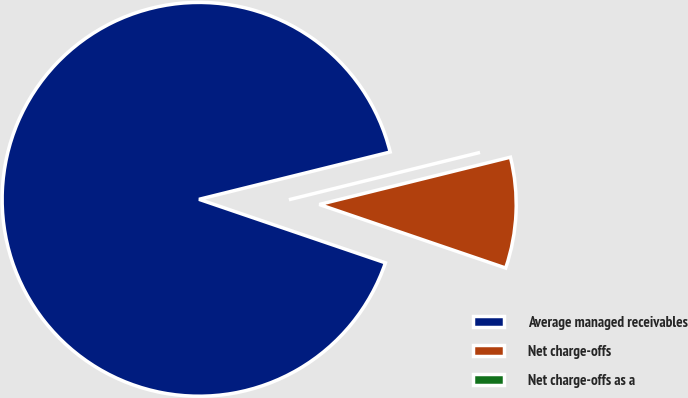Convert chart to OTSL. <chart><loc_0><loc_0><loc_500><loc_500><pie_chart><fcel>Average managed receivables<fcel>Net charge-offs<fcel>Net charge-offs as a<nl><fcel>90.91%<fcel>9.09%<fcel>0.0%<nl></chart> 